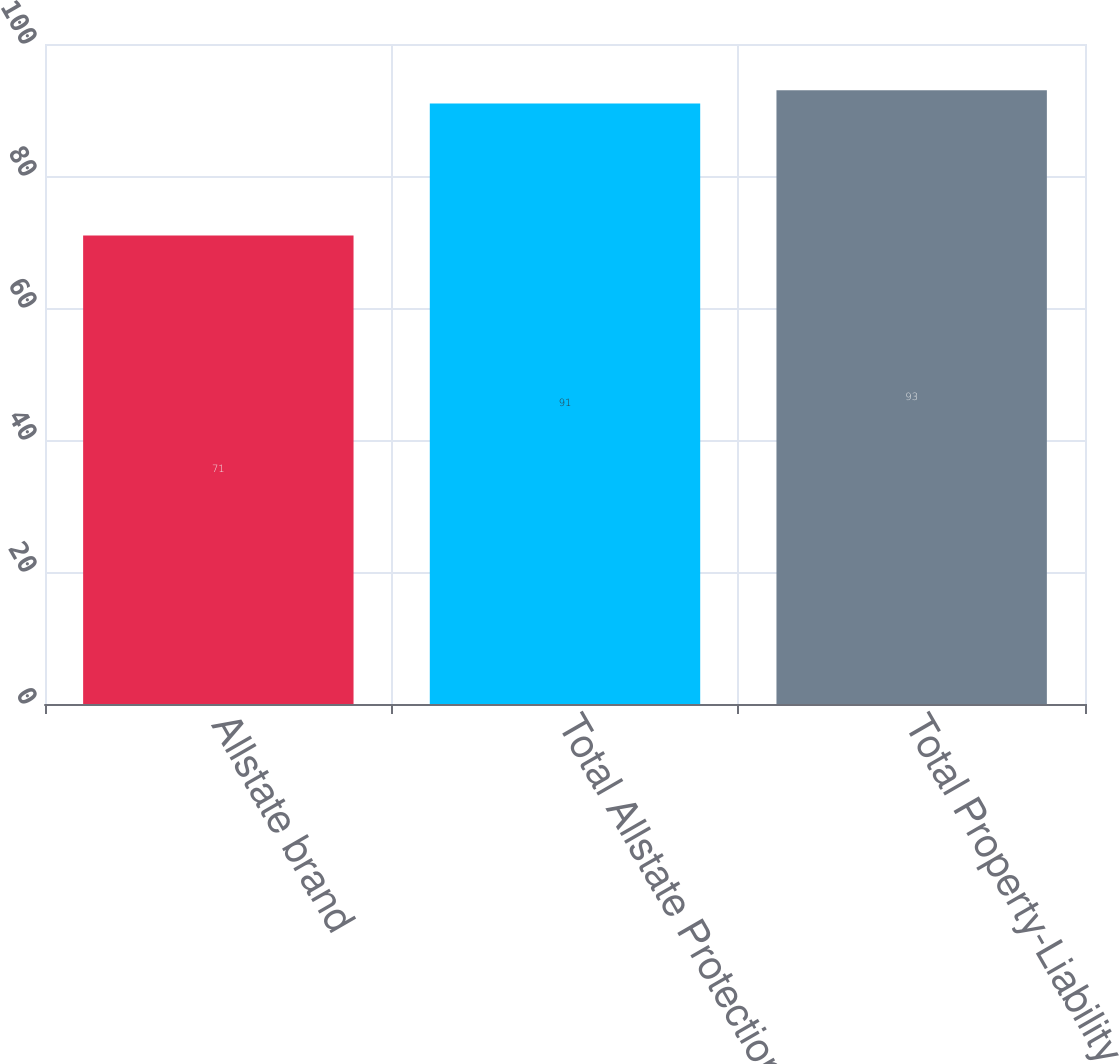<chart> <loc_0><loc_0><loc_500><loc_500><bar_chart><fcel>Allstate brand<fcel>Total Allstate Protection<fcel>Total Property-Liability<nl><fcel>71<fcel>91<fcel>93<nl></chart> 